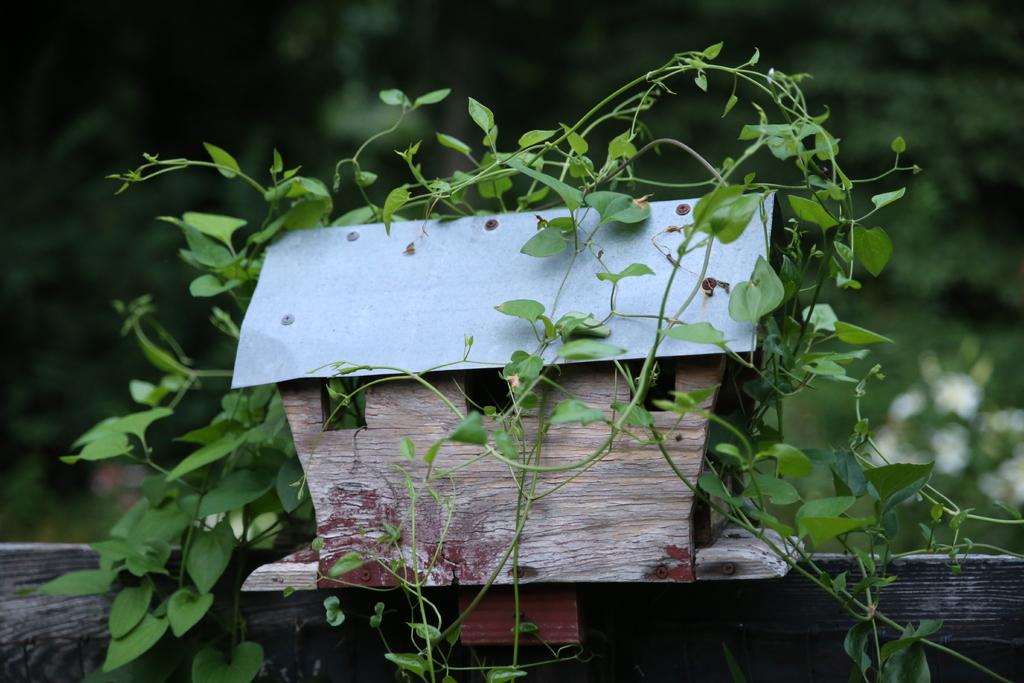What is the main subject of the image? The main subject of the image is a miniature house. What can be seen on the miniature house? There are plants on the miniature house. How would you describe the background of the image? The background of the image is blurry. What type of advertisement can be seen on the miniature house? There is no advertisement present on the miniature house in the image. How many rings are visible on the plants in the image? There are no rings visible on the plants in the image. 